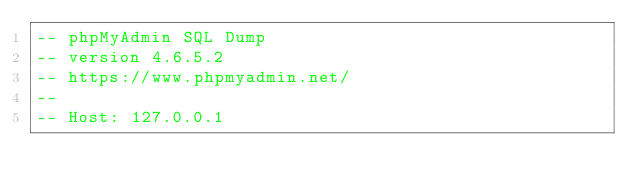Convert code to text. <code><loc_0><loc_0><loc_500><loc_500><_SQL_>-- phpMyAdmin SQL Dump
-- version 4.6.5.2
-- https://www.phpmyadmin.net/
--
-- Host: 127.0.0.1</code> 